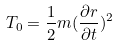Convert formula to latex. <formula><loc_0><loc_0><loc_500><loc_500>T _ { 0 } = \frac { 1 } { 2 } m ( \frac { \partial r } { \partial t } ) ^ { 2 }</formula> 